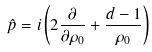<formula> <loc_0><loc_0><loc_500><loc_500>\hat { p } = i \left ( 2 \frac { \partial } { \partial \rho _ { 0 } } + \frac { d - 1 } { \rho _ { 0 } } \right )</formula> 